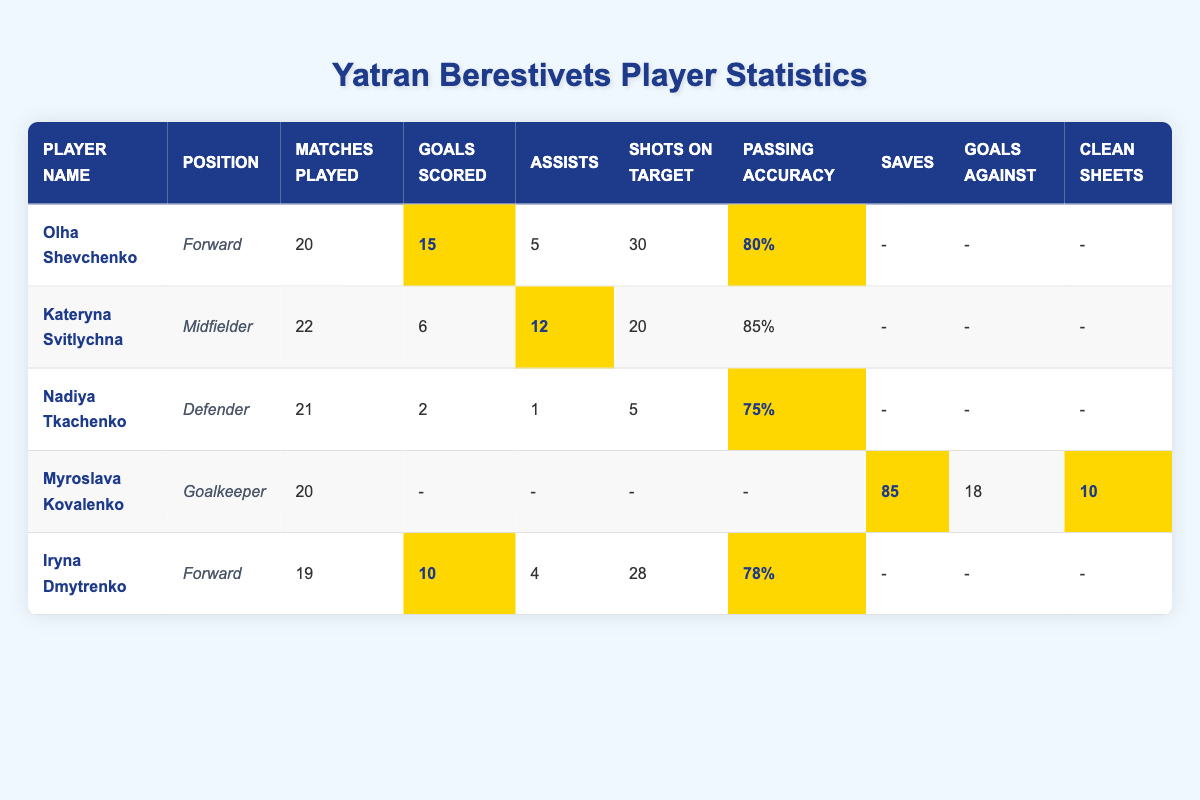What is the highest number of goals scored by a player? In the table, the highest number of goals scored is 15 by Olha Shevchenko.
Answer: 15 Which player has the most assists? Kateryna Svitlychna has the most assists, with a total of 12.
Answer: 12 How many matches did Iryna Dmytrenko play? Iryna Dmytrenko played 19 matches, as indicated in the table.
Answer: 19 What is the average passing accuracy of all players? The passing accuracy for the players is 80%, 85%, 75%, —, — (not applicable for goalkeeper), 78%. The average of the valid values (80%, 85%, 75%, 78%) is (80 + 85 + 75 + 78) / 4 = 79.5%.
Answer: 79.5% How many total goals have been scored by all forwards? The total goals scored by forwards Olha Shevchenko (15) and Iryna Dmytrenko (10) is 15 + 10 = 25.
Answer: 25 Does Myroslava Kovalenko have more saves or clean sheets? Myroslava Kovalenko has 85 saves and 10 clean sheets. Since 85 is greater than 10, she has more saves than clean sheets.
Answer: Yes Who is the only player without goals scored? The only player without goals scored is Nadiya Tkachenko, who is a defender with 2 goals scored.
Answer: Nadiya Tkachenko What is the total number of assists from all players? The total number of assists is the sum of assists from each player: 5 (Olha) + 12 (Kateryna) + 1 (Nadiya) + 0 (Myroslava) + 4 (Iryna) = 22 assists.
Answer: 22 Which player has the lowest passing accuracy? Nadiya Tkachenko has the lowest passing accuracy at 75%.
Answer: 75% Is there a player who has a clean sheet? Yes, Myroslava Kovalenko has recorded 10 clean sheets as a goalkeeper.
Answer: Yes 